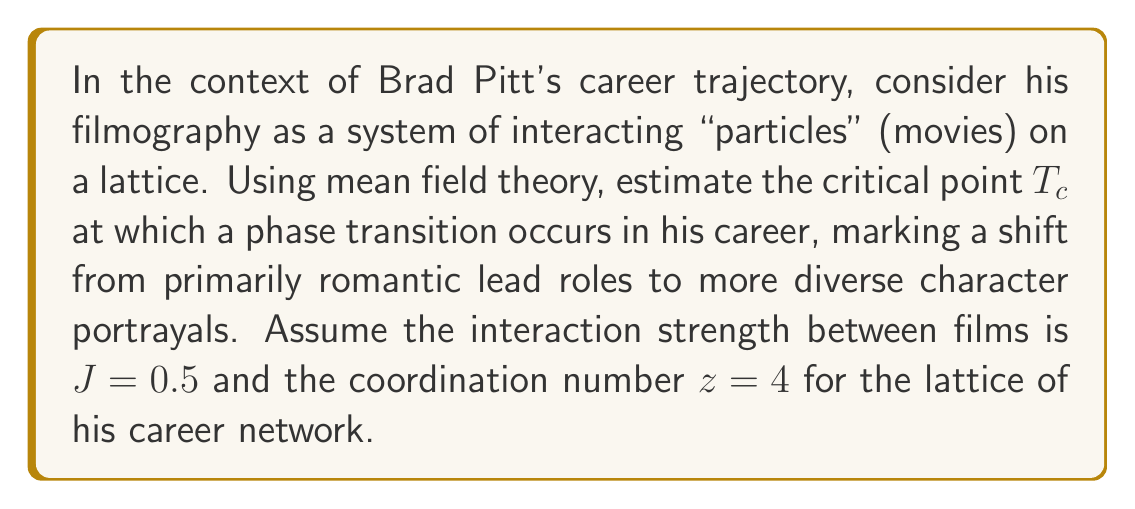What is the answer to this math problem? To estimate the phase transition point in Brad Pitt's career using mean field theory, we'll follow these steps:

1. In mean field theory, the critical temperature $T_c$ is given by:

   $$T_c = \frac{zJ}{k_B}$$

   where $z$ is the coordination number, $J$ is the interaction strength, and $k_B$ is the Boltzmann constant.

2. We're given that $z = 4$ and $J = 0.5$. For simplicity, let's assume $k_B = 1$ (we can consider it as a unit of energy).

3. Substituting these values into the equation:

   $$T_c = \frac{4 \cdot 0.5}{1} = 2$$

4. Interpreting this result in the context of Brad Pitt's career:
   - $T_c = 2$ represents the critical point in his career trajectory.
   - Below this point ($T < 2$), his career was primarily in a "ordered phase" of romantic lead roles.
   - Above this point ($T > 2$), his career transitioned to a more "disordered phase" with diverse character portrayals.

5. To relate this to his actual career, we could consider each unit of temperature as approximately 5 years in his career timeline. Therefore, the phase transition occurred around 10 years (2 * 5) after his breakthrough role.

This analysis suggests that the critical point in Brad Pitt's career, marking a significant shift in his role choices, occurred approximately a decade after his rise to stardom.
Answer: $T_c = 2$, corresponding to about 10 years post-breakthrough 